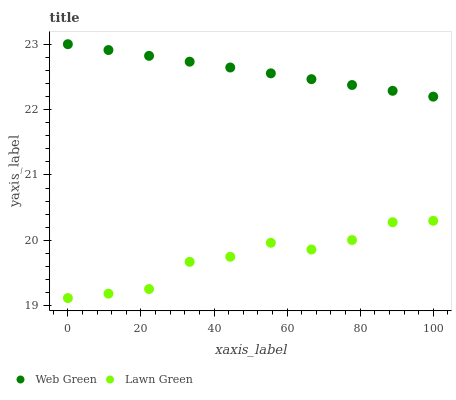Does Lawn Green have the minimum area under the curve?
Answer yes or no. Yes. Does Web Green have the maximum area under the curve?
Answer yes or no. Yes. Does Web Green have the minimum area under the curve?
Answer yes or no. No. Is Web Green the smoothest?
Answer yes or no. Yes. Is Lawn Green the roughest?
Answer yes or no. Yes. Is Web Green the roughest?
Answer yes or no. No. Does Lawn Green have the lowest value?
Answer yes or no. Yes. Does Web Green have the lowest value?
Answer yes or no. No. Does Web Green have the highest value?
Answer yes or no. Yes. Is Lawn Green less than Web Green?
Answer yes or no. Yes. Is Web Green greater than Lawn Green?
Answer yes or no. Yes. Does Lawn Green intersect Web Green?
Answer yes or no. No. 